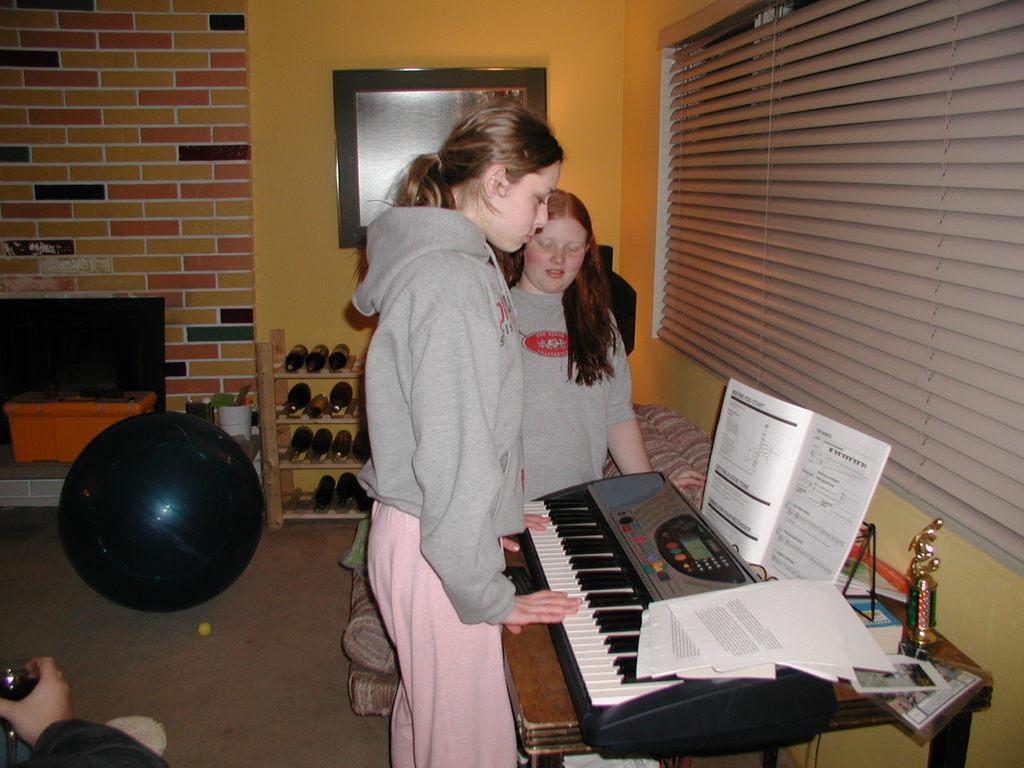In one or two sentences, can you explain what this image depicts? There is a woman standing in the center and she is playing a piano. There is another woman standing beside to this woman and she is looking at this piano. 